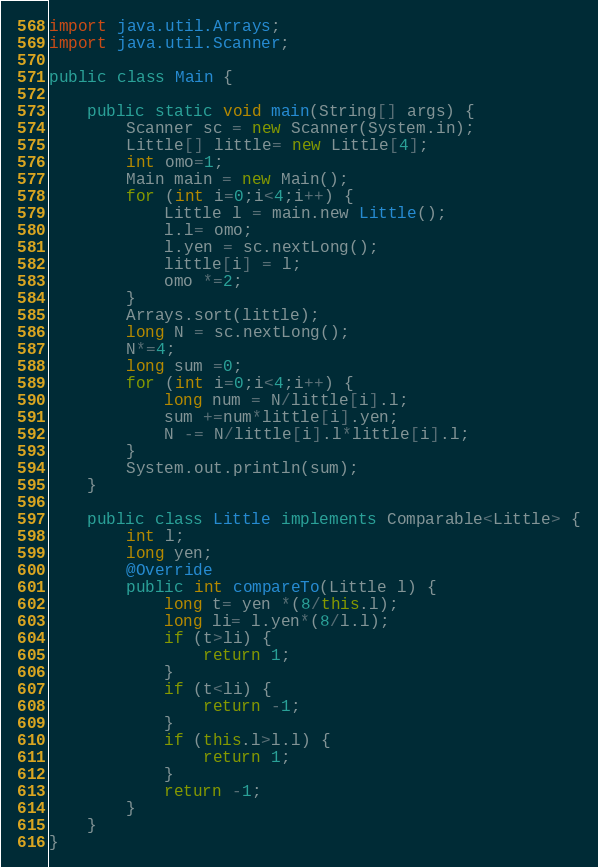<code> <loc_0><loc_0><loc_500><loc_500><_Java_>import java.util.Arrays;
import java.util.Scanner;

public class Main {

	public static void main(String[] args) {
		Scanner sc = new Scanner(System.in);
		Little[] little= new Little[4];
		int omo=1;
		Main main = new Main();
		for (int i=0;i<4;i++) {
			Little l = main.new Little();
			l.l= omo;
			l.yen = sc.nextLong();
			little[i] = l;
			omo *=2;
		}
		Arrays.sort(little);
		long N = sc.nextLong();
		N*=4;
		long sum =0;
		for (int i=0;i<4;i++) {
			long num = N/little[i].l;
			sum +=num*little[i].yen;
			N -= N/little[i].l*little[i].l;
		}
		System.out.println(sum);
	}

	public class Little implements Comparable<Little> {
		int l;
		long yen;
		@Override
		public int compareTo(Little l) {
			long t= yen *(8/this.l);
			long li= l.yen*(8/l.l);
			if (t>li) {
				return 1;
			}
			if (t<li) {
				return -1;
			}
			if (this.l>l.l) {
				return 1;
			}
			return -1;
		}
	}
}</code> 